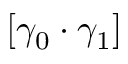<formula> <loc_0><loc_0><loc_500><loc_500>[ \gamma _ { 0 } \cdot \gamma _ { 1 } ]</formula> 